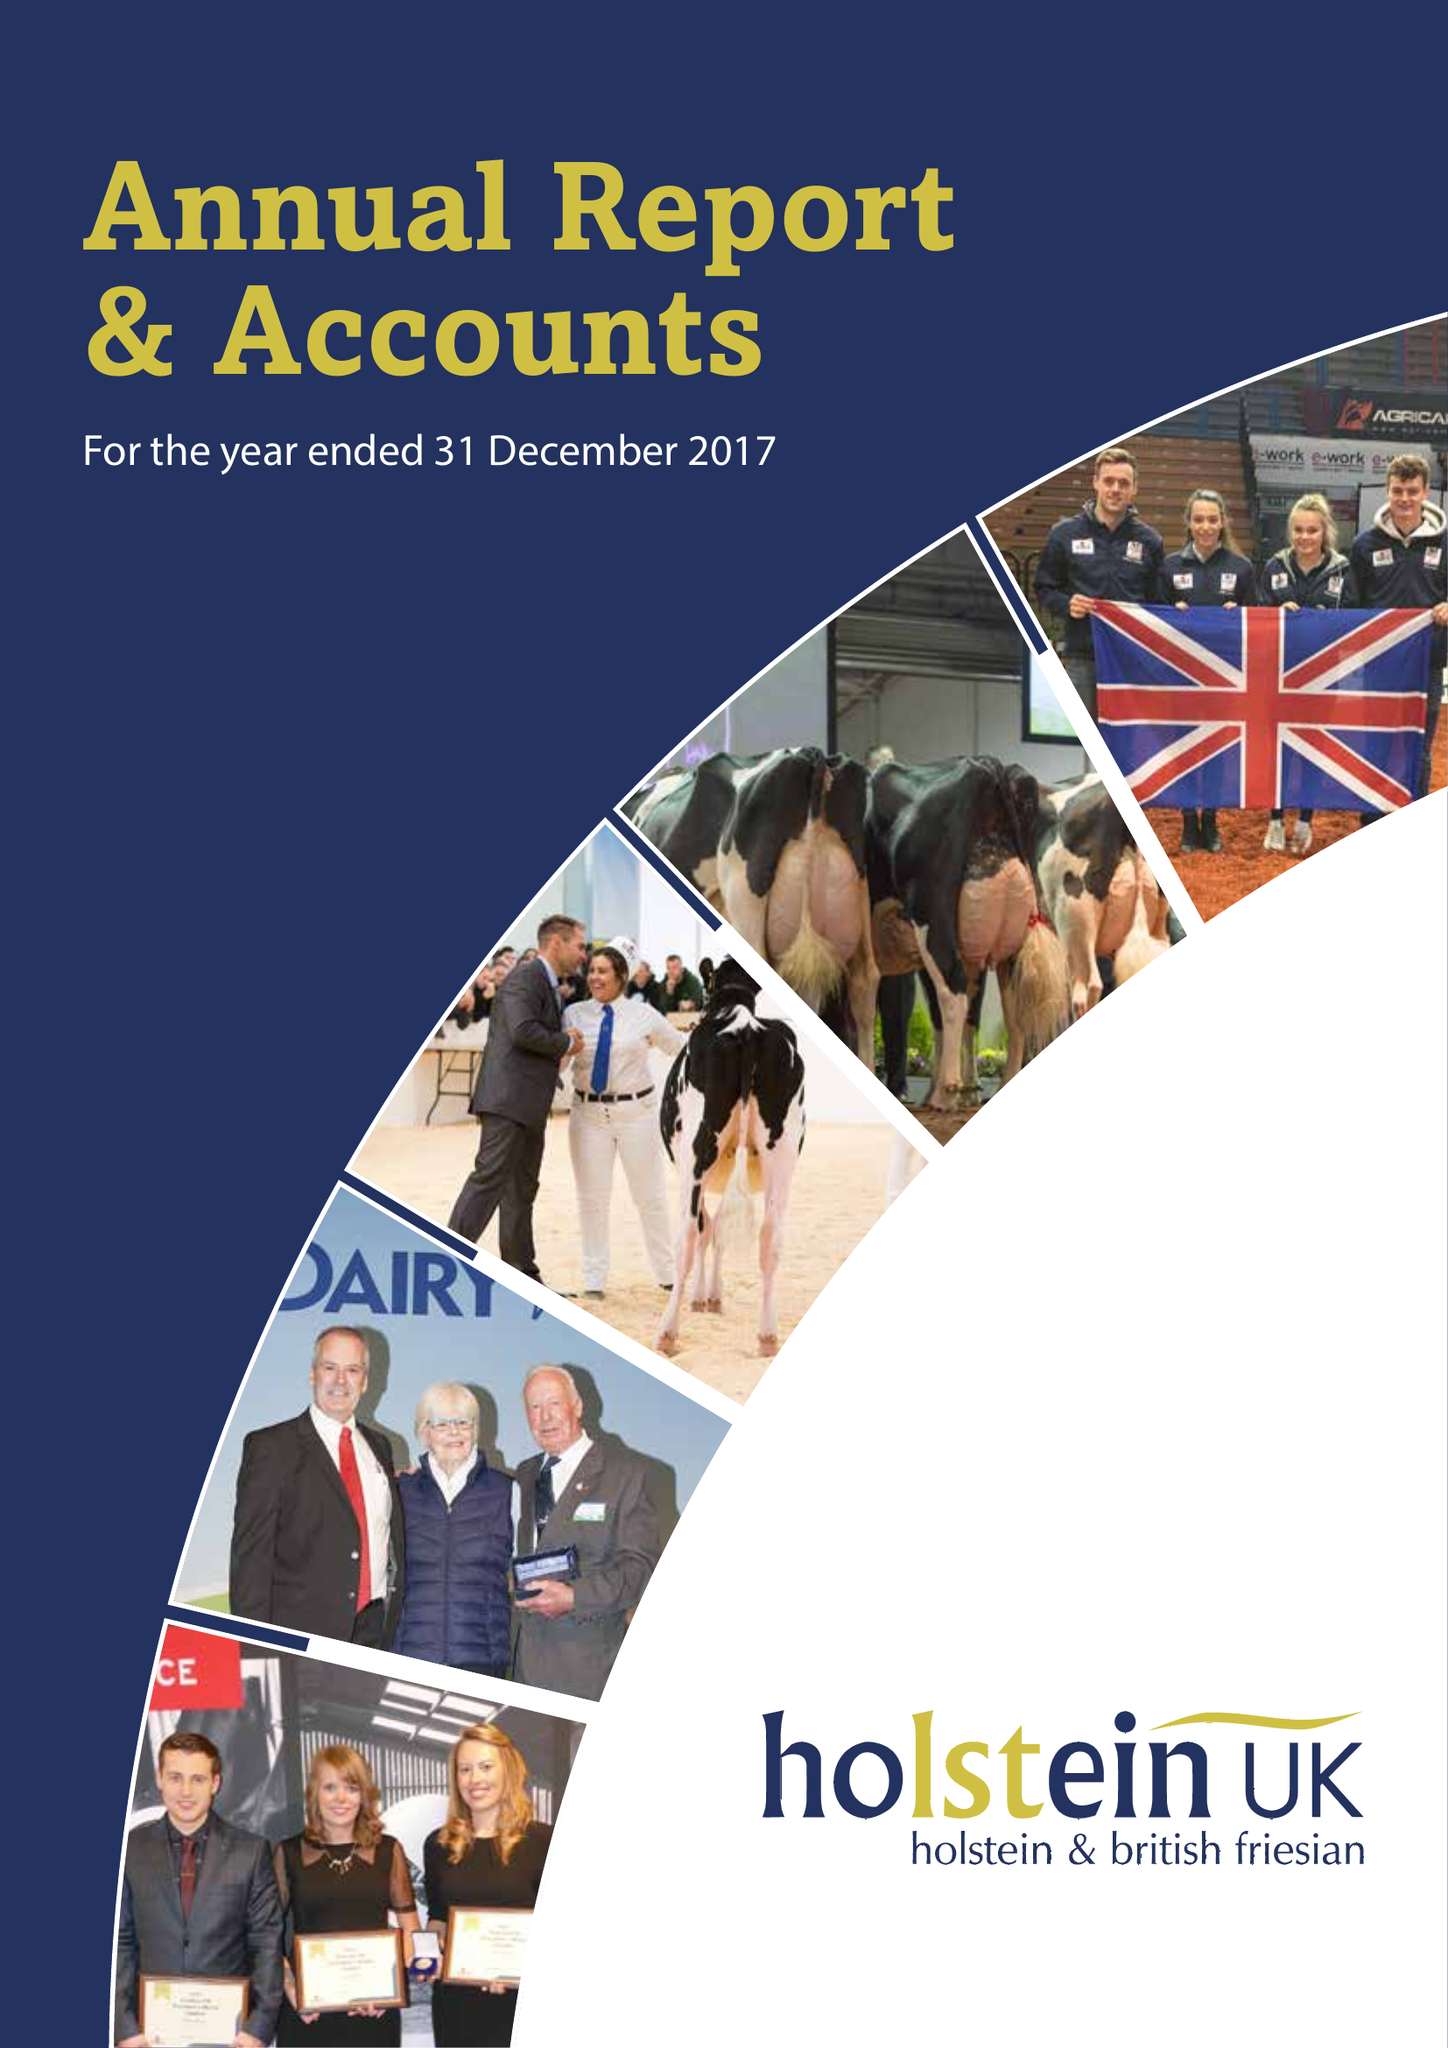What is the value for the report_date?
Answer the question using a single word or phrase. 2017-12-31 